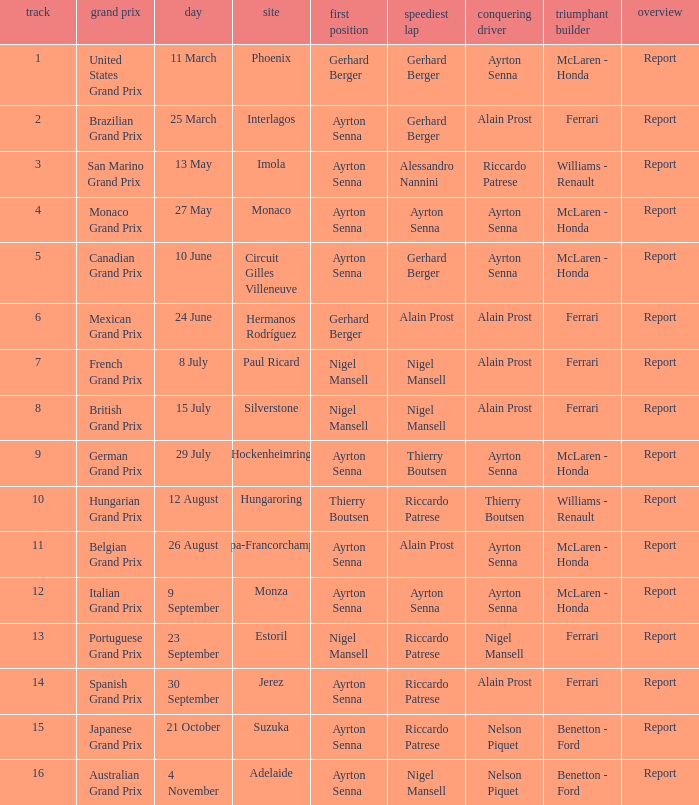What is the date that Ayrton Senna was the drive in Monza? 9 September. 